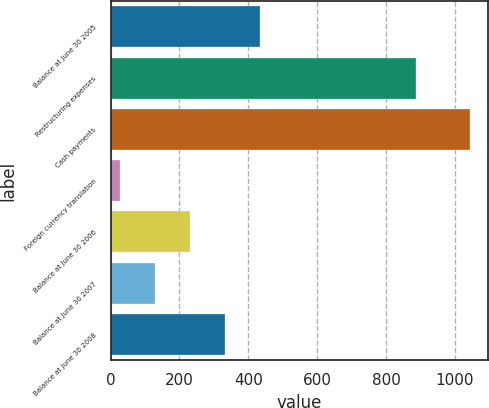<chart> <loc_0><loc_0><loc_500><loc_500><bar_chart><fcel>Balance at June 30 2005<fcel>Restructuring expenses<fcel>Cash payments<fcel>Foreign currency translation<fcel>Balance at June 30 2006<fcel>Balance at June 30 2007<fcel>Balance at June 30 2008<nl><fcel>434.4<fcel>888<fcel>1044<fcel>28<fcel>231.2<fcel>129.6<fcel>332.8<nl></chart> 